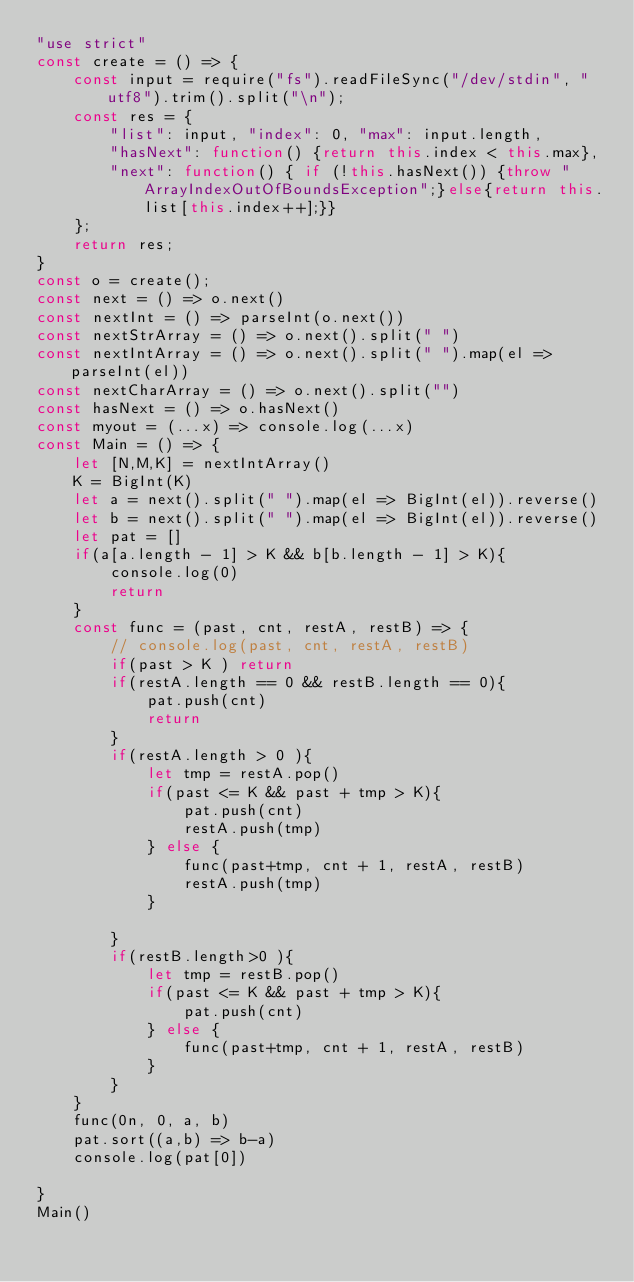Convert code to text. <code><loc_0><loc_0><loc_500><loc_500><_JavaScript_>"use strict"
const create = () => {
    const input = require("fs").readFileSync("/dev/stdin", "utf8").trim().split("\n");
    const res = {
        "list": input, "index": 0, "max": input.length,
        "hasNext": function() {return this.index < this.max},
        "next": function() { if (!this.hasNext()) {throw "ArrayIndexOutOfBoundsException";}else{return this.list[this.index++];}}
    };
    return res;
}
const o = create();
const next = () => o.next()
const nextInt = () => parseInt(o.next())
const nextStrArray = () => o.next().split(" ")
const nextIntArray = () => o.next().split(" ").map(el => parseInt(el))
const nextCharArray = () => o.next().split("")
const hasNext = () => o.hasNext()
const myout = (...x) => console.log(...x)
const Main = () => {
    let [N,M,K] = nextIntArray()
    K = BigInt(K)
    let a = next().split(" ").map(el => BigInt(el)).reverse()
    let b = next().split(" ").map(el => BigInt(el)).reverse()
    let pat = []
    if(a[a.length - 1] > K && b[b.length - 1] > K){
        console.log(0)
        return
    }
    const func = (past, cnt, restA, restB) => {
        // console.log(past, cnt, restA, restB)
        if(past > K ) return
        if(restA.length == 0 && restB.length == 0){
            pat.push(cnt)
            return
        }
        if(restA.length > 0 ){
            let tmp = restA.pop()
            if(past <= K && past + tmp > K){
                pat.push(cnt)
                restA.push(tmp)
            } else {
                func(past+tmp, cnt + 1, restA, restB)
                restA.push(tmp)
            }

        }
        if(restB.length>0 ){
            let tmp = restB.pop()
            if(past <= K && past + tmp > K){
                pat.push(cnt)
            } else {
                func(past+tmp, cnt + 1, restA, restB)
            }
        }
    }
    func(0n, 0, a, b)
    pat.sort((a,b) => b-a)
    console.log(pat[0])

}
Main()
</code> 